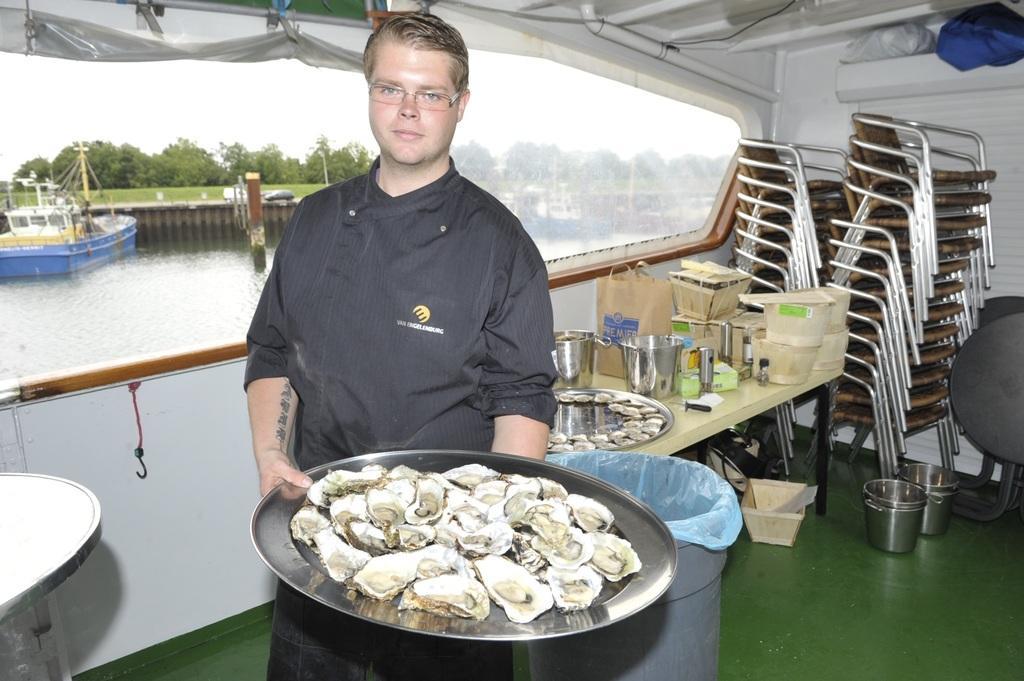Please provide a concise description of this image. In this picture I can see a man holding some food in the tray and I can see a dustbin and few vessels and a paper bag and food in another plate on the table and few vessels on the floor and bunch of chairs and a table and it looks like a inner view of a boat and I can see few boats in the water and trees and a cloudy sky. 